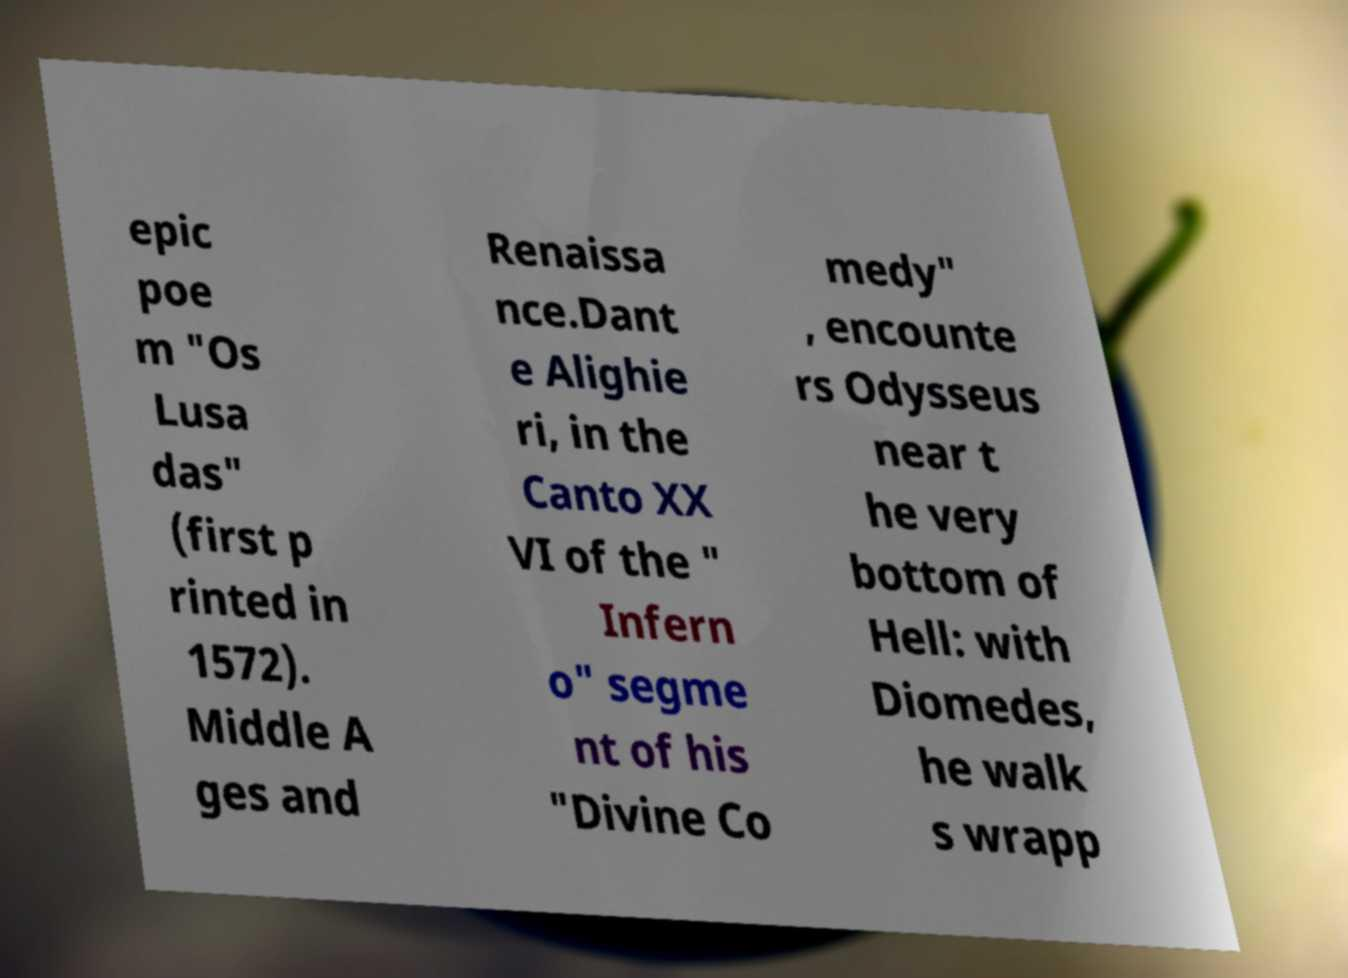Can you accurately transcribe the text from the provided image for me? epic poe m "Os Lusa das" (first p rinted in 1572). Middle A ges and Renaissa nce.Dant e Alighie ri, in the Canto XX VI of the " Infern o" segme nt of his "Divine Co medy" , encounte rs Odysseus near t he very bottom of Hell: with Diomedes, he walk s wrapp 